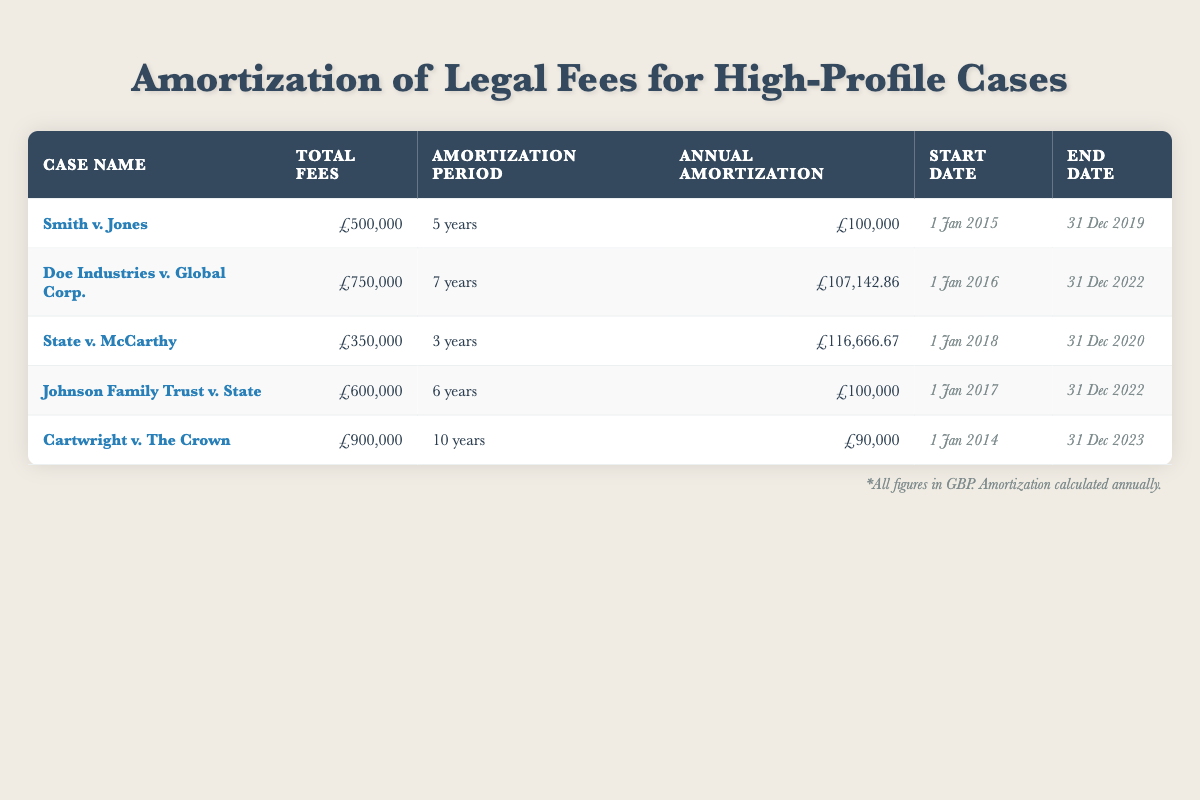What is the total amount of legal fees for the case "Cartwright v. The Crown"? The table indicates that the total fees listed for the case "Cartwright v. The Crown" are £900,000.
Answer: £900,000 How many years does the case "Doe Industries v. Global Corp." take to amortize its fees? The amortization period for "Doe Industries v. Global Corp." is 7 years, as indicated in the corresponding column of the table.
Answer: 7 years What is the annual amortization amount for the case "State v. McCarthy"? The table shows that the annual amortization for "State v. McCarthy" is £116,666.67, which is provided directly in the annual amortization column.
Answer: £116,666.67 Which case has the longest amortization period? By comparing the amortization periods in the table, "Cartwright v. The Crown" has the longest amortization period at 10 years.
Answer: Cartwright v. The Crown What is the average annual amortization amount across all cases? The annual amortization amounts are £100,000, £107,142.86, £116,666.67, £100,000, and £90,000. Summing these gives £513,809.53. Dividing this total by 5 cases results in an average of £102,761.91.
Answer: £102,761.91 Is the total fees for "Smith v. Jones" equal to the total fees for "Johnson Family Trust v. State"? By examining the total fees, "Smith v. Jones" has total fees of £500,000 and "Johnson Family Trust v. State" also has total fees of £600,000, which are not equal.
Answer: No How much greater is the total legal fees of "Doe Industries v. Global Corp." compared to "State v. McCarthy"? The total fees for "Doe Industries v. Global Corp." are £750,000, while for "State v. McCarthy" they are £350,000. The difference is £750,000 - £350,000, resulting in £400,000.
Answer: £400,000 Does any case amortize its fees over a period greater than 7 years? The table shows that "Cartwright v. The Crown" has an amortization period of 10 years, which is greater than 7 years.
Answer: Yes What is the total amortized amount over the term for the case "Johnson Family Trust v. State"? The annual amortization for "Johnson Family Trust v. State" is £100,000 for a period of 6 years. Thus, the total is calculated as £100,000 times 6 years, resulting in £600,000.
Answer: £600,000 